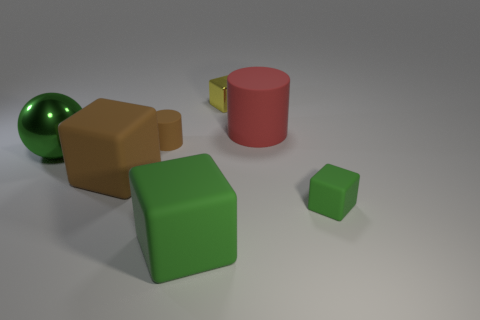Subtract 1 cubes. How many cubes are left? 3 Add 3 large cylinders. How many objects exist? 10 Subtract all balls. How many objects are left? 6 Add 7 big green shiny things. How many big green shiny things exist? 8 Subtract 1 brown cylinders. How many objects are left? 6 Subtract all tiny objects. Subtract all large green blocks. How many objects are left? 3 Add 4 tiny brown matte things. How many tiny brown matte things are left? 5 